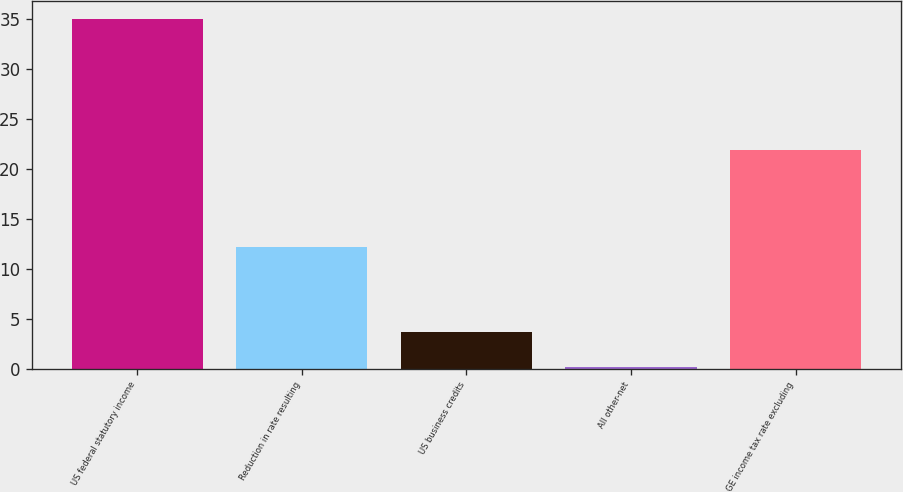Convert chart. <chart><loc_0><loc_0><loc_500><loc_500><bar_chart><fcel>US federal statutory income<fcel>Reduction in rate resulting<fcel>US business credits<fcel>All other-net<fcel>GE income tax rate excluding<nl><fcel>35<fcel>12.2<fcel>3.68<fcel>0.2<fcel>21.9<nl></chart> 